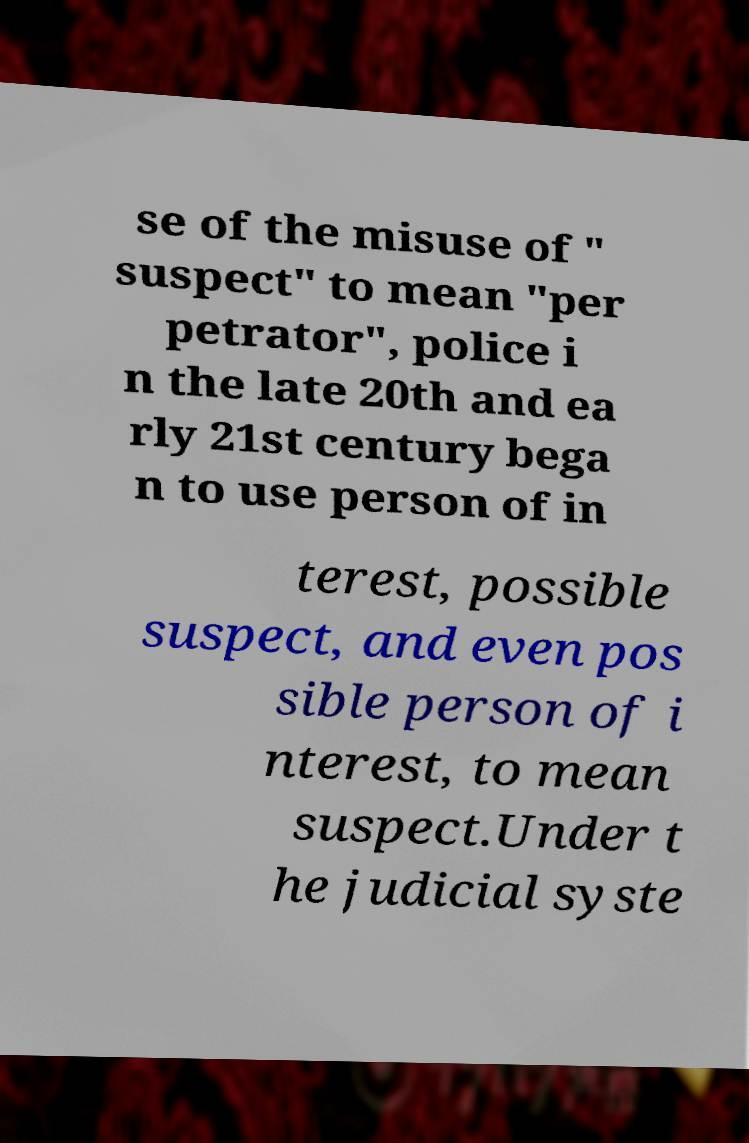Can you accurately transcribe the text from the provided image for me? se of the misuse of " suspect" to mean "per petrator", police i n the late 20th and ea rly 21st century bega n to use person of in terest, possible suspect, and even pos sible person of i nterest, to mean suspect.Under t he judicial syste 